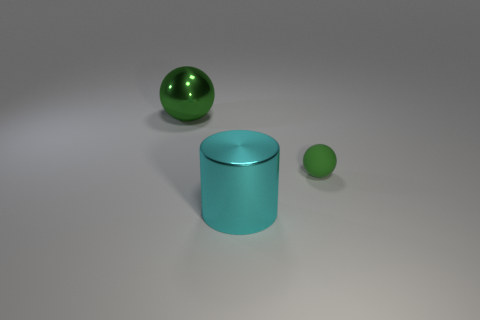Add 2 red shiny objects. How many objects exist? 5 Subtract all cylinders. How many objects are left? 2 Subtract 0 gray spheres. How many objects are left? 3 Subtract all green shiny spheres. Subtract all red metallic cylinders. How many objects are left? 2 Add 2 large cylinders. How many large cylinders are left? 3 Add 1 large green cubes. How many large green cubes exist? 1 